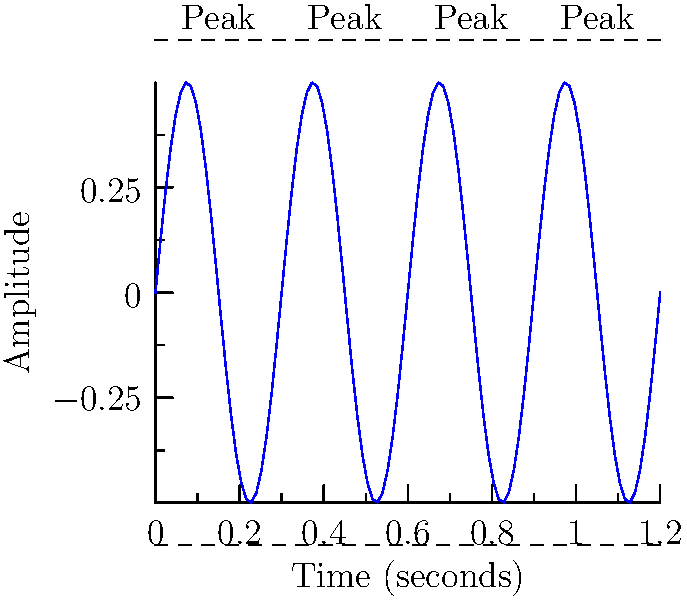As a mindfulness coach incorporating music into stress management techniques, you're analyzing a waveform of a calming musical piece. The graph shows the amplitude of the sound wave over time. If the distance between each peak represents one beat, calculate the tempo of this piece in beats per minute (BPM). Round your answer to the nearest whole number. To calculate the beats per minute (BPM), we need to follow these steps:

1) First, identify the time interval between two consecutive peaks. From the graph, we can see that the peaks occur at regular intervals of 0.3 seconds.

2) Calculate how many beats occur in one minute:
   - There are 60 seconds in a minute
   - Each beat takes 0.3 seconds
   - Number of beats in a minute = $\frac{60 \text{ seconds}}{0.3 \text{ seconds per beat}}$

3) Perform the calculation:
   $\text{BPM} = \frac{60}{0.3} = 200$

4) The question asks to round to the nearest whole number, but 200 is already a whole number, so no rounding is necessary.

This tempo of 200 BPM would be considered quite fast and energetic. For stress management and mindfulness practices, you might typically use music with a slower tempo, often around 60-80 BPM, which is closer to the resting heart rate and can help induce a calmer state.
Answer: 200 BPM 